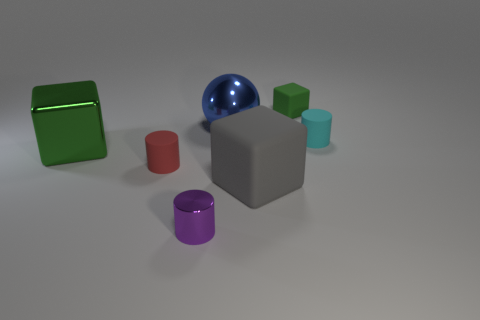Can you describe the arrangement of the objects and what it might suggest about their use or purpose? The objects are strategically placed with adequate space between them, which could imply they’re part of a display or set for demonstration. Their varied shapes and colors might represent a showcase of geometric forms or a sample set from a product line. 